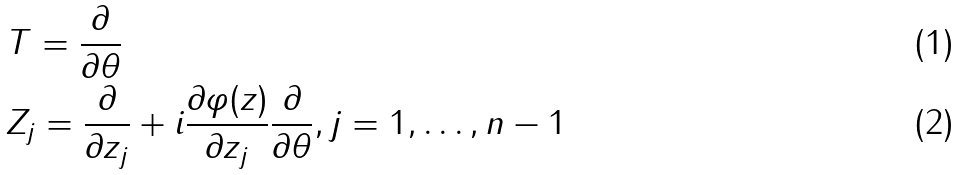<formula> <loc_0><loc_0><loc_500><loc_500>& T = \frac { \partial } { \partial \theta } \\ & Z _ { j } = \frac { \partial } { \partial z _ { j } } + i \frac { \partial \varphi ( z ) } { \partial z _ { j } } \frac { \partial } { \partial \theta } , j = 1 , \dots , n - 1</formula> 